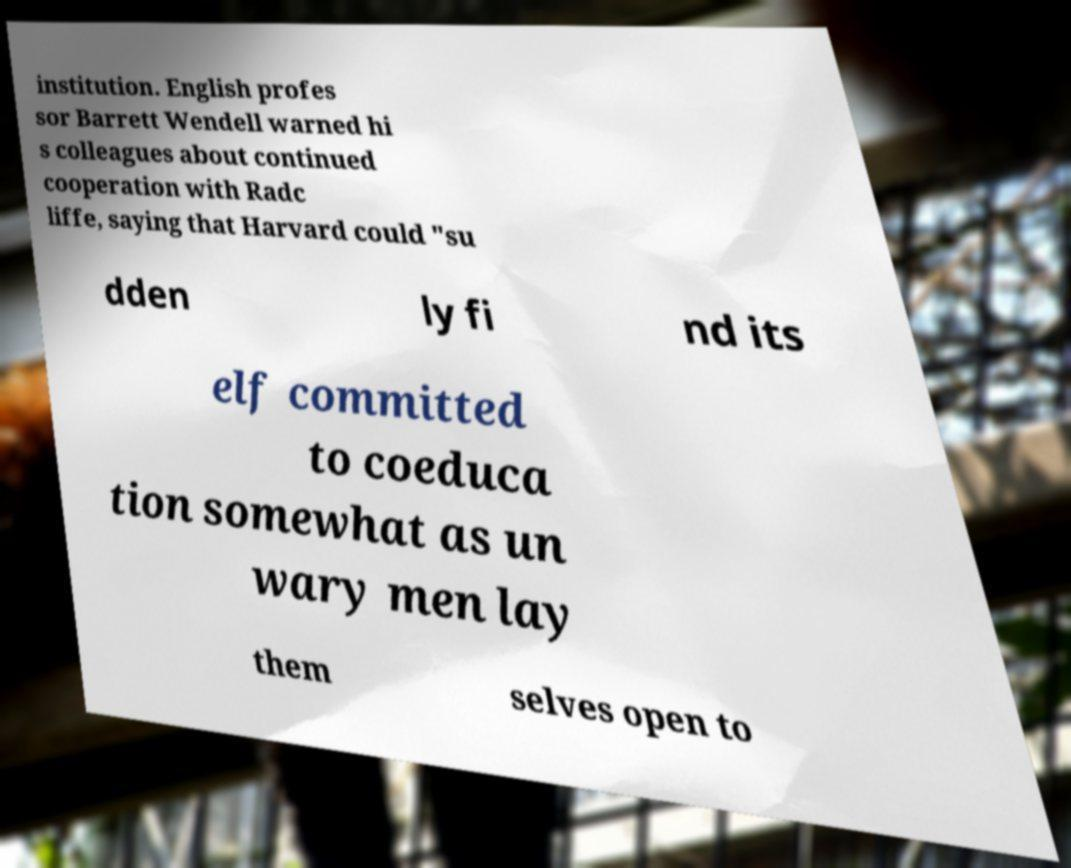Please read and relay the text visible in this image. What does it say? institution. English profes sor Barrett Wendell warned hi s colleagues about continued cooperation with Radc liffe, saying that Harvard could "su dden ly fi nd its elf committed to coeduca tion somewhat as un wary men lay them selves open to 